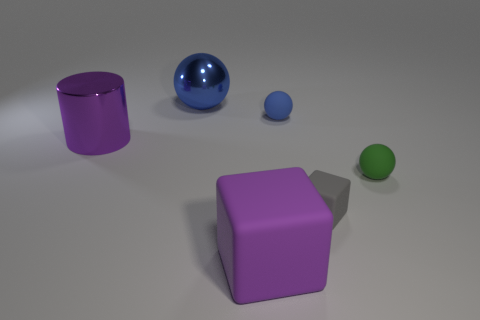What is the size of the other blue thing that is the same shape as the tiny blue thing?
Provide a short and direct response. Large. What is the material of the sphere that is both in front of the metallic sphere and to the left of the gray cube?
Give a very brief answer. Rubber. Does the large thing that is in front of the big shiny cylinder have the same color as the large cylinder?
Make the answer very short. Yes. There is a shiny sphere; is it the same color as the tiny ball that is in front of the cylinder?
Make the answer very short. No. Are there any purple things behind the tiny gray block?
Make the answer very short. Yes. Is the tiny green sphere made of the same material as the large blue object?
Provide a succinct answer. No. There is a block that is the same size as the green ball; what is it made of?
Offer a very short reply. Rubber. What number of things are balls that are to the right of the large purple block or big rubber blocks?
Offer a terse response. 3. Is the number of big blocks that are on the right side of the purple matte thing the same as the number of purple rubber cylinders?
Provide a succinct answer. Yes. Is the color of the large metallic cylinder the same as the large matte thing?
Make the answer very short. Yes. 